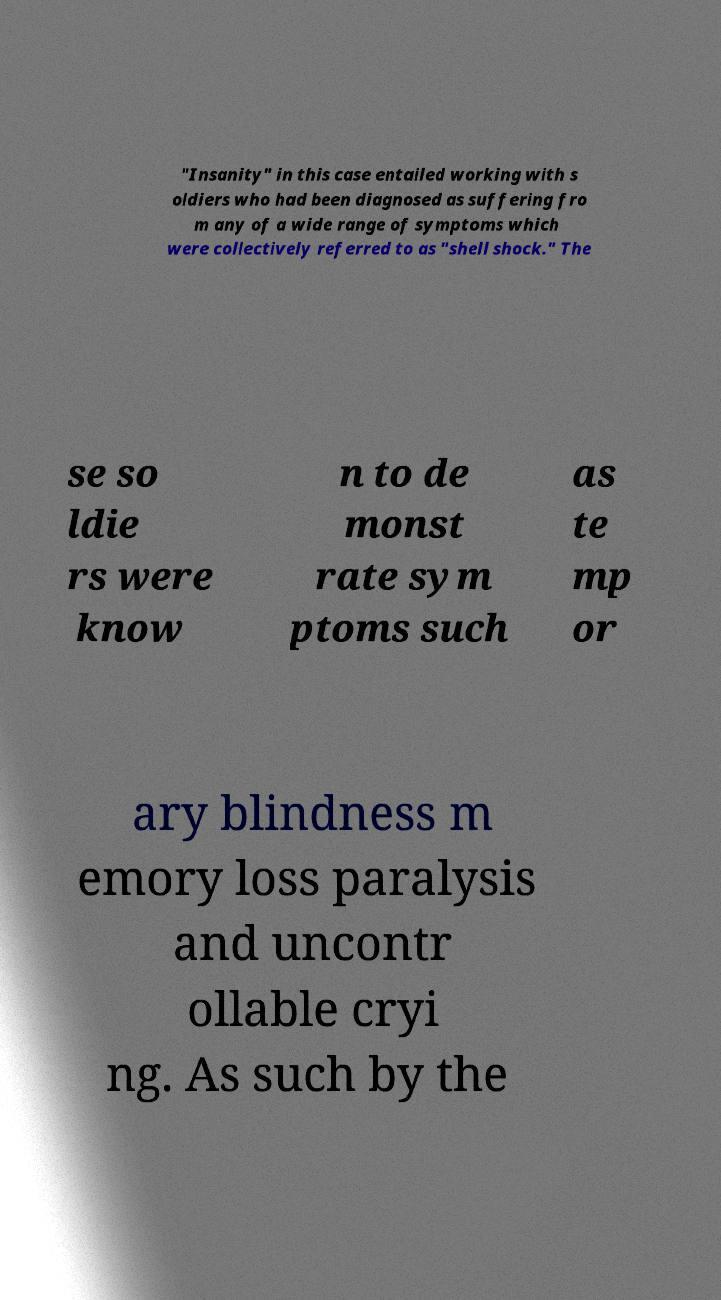I need the written content from this picture converted into text. Can you do that? "Insanity" in this case entailed working with s oldiers who had been diagnosed as suffering fro m any of a wide range of symptoms which were collectively referred to as "shell shock." The se so ldie rs were know n to de monst rate sym ptoms such as te mp or ary blindness m emory loss paralysis and uncontr ollable cryi ng. As such by the 